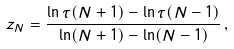<formula> <loc_0><loc_0><loc_500><loc_500>z _ { N } = \frac { \ln \tau ( N + 1 ) - \ln \tau ( N - 1 ) } { \ln ( N + 1 ) - \ln ( N - 1 ) } \, ,</formula> 